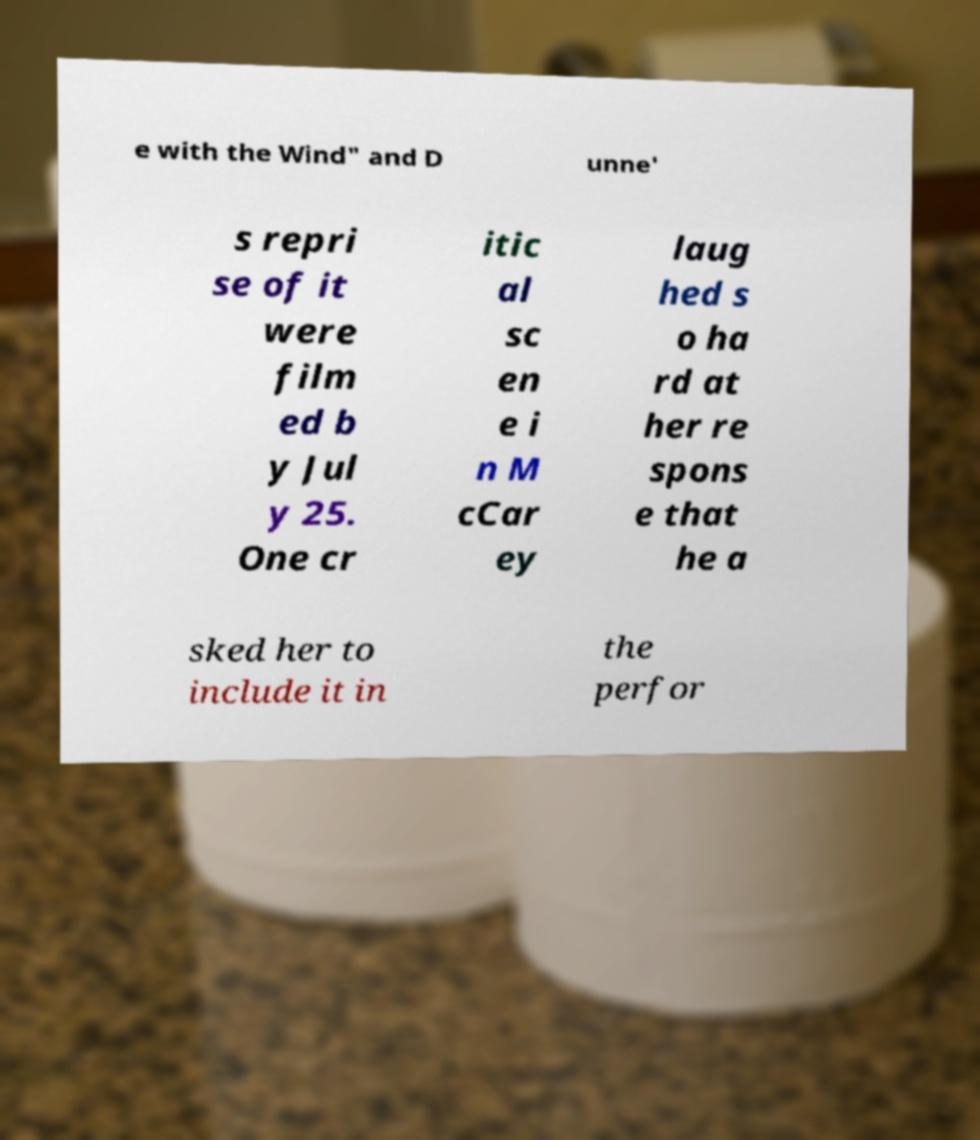I need the written content from this picture converted into text. Can you do that? e with the Wind" and D unne' s repri se of it were film ed b y Jul y 25. One cr itic al sc en e i n M cCar ey laug hed s o ha rd at her re spons e that he a sked her to include it in the perfor 